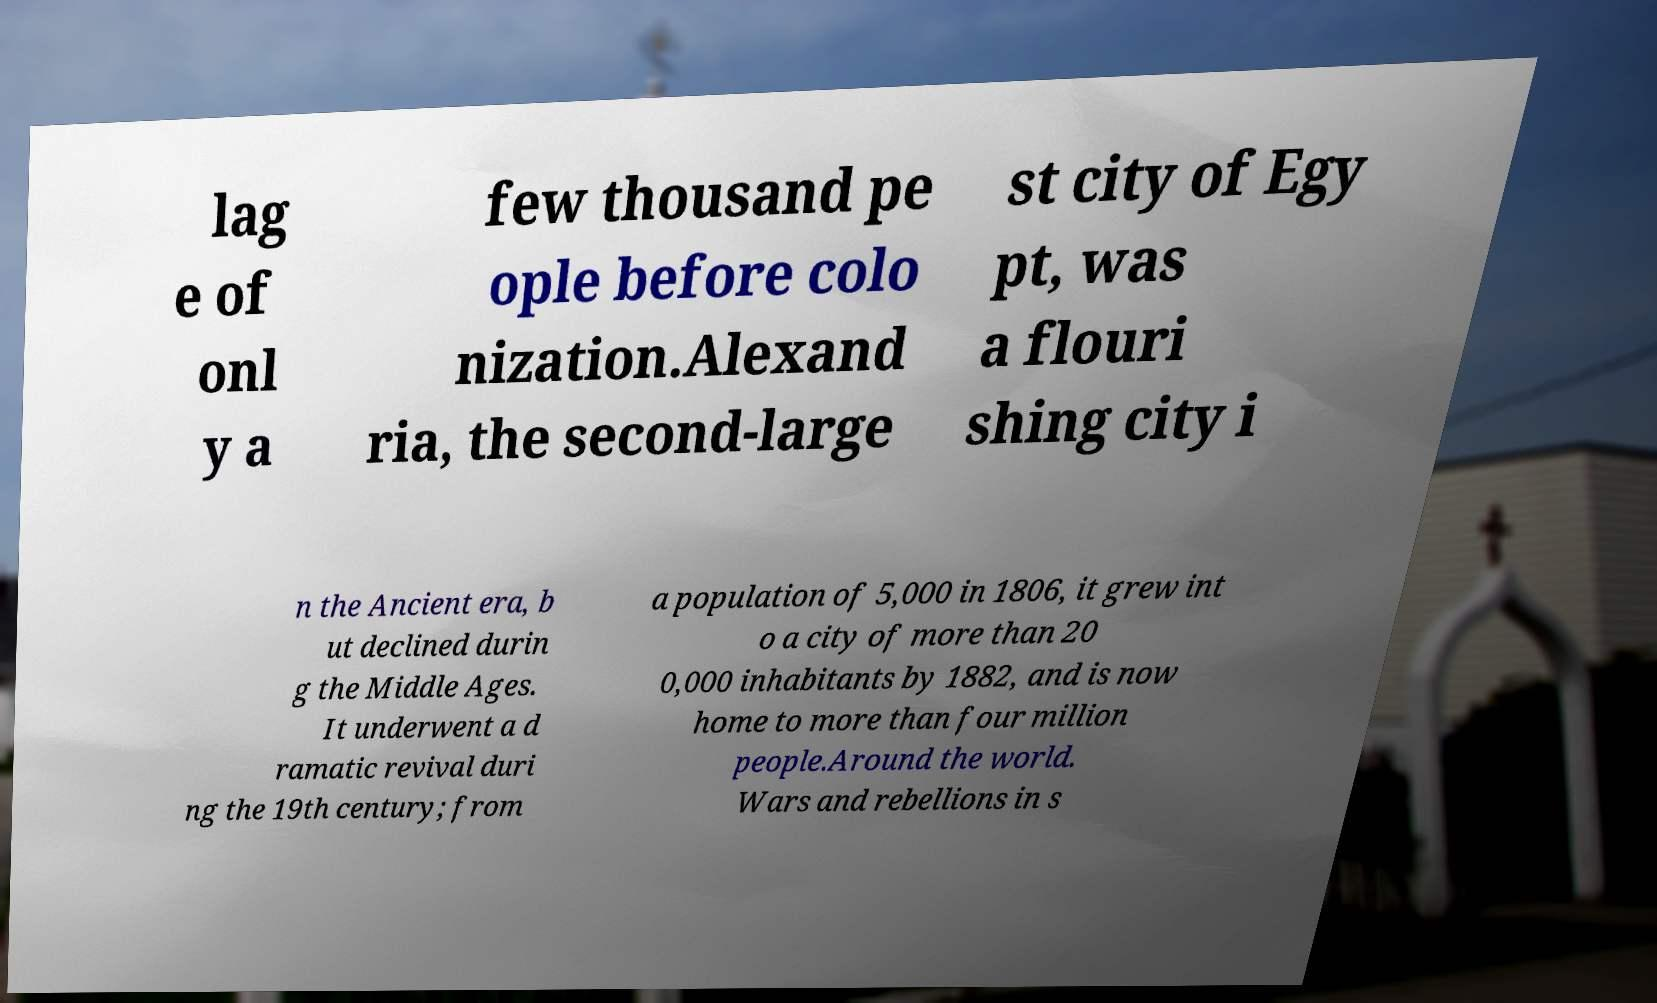Could you extract and type out the text from this image? lag e of onl y a few thousand pe ople before colo nization.Alexand ria, the second-large st city of Egy pt, was a flouri shing city i n the Ancient era, b ut declined durin g the Middle Ages. It underwent a d ramatic revival duri ng the 19th century; from a population of 5,000 in 1806, it grew int o a city of more than 20 0,000 inhabitants by 1882, and is now home to more than four million people.Around the world. Wars and rebellions in s 